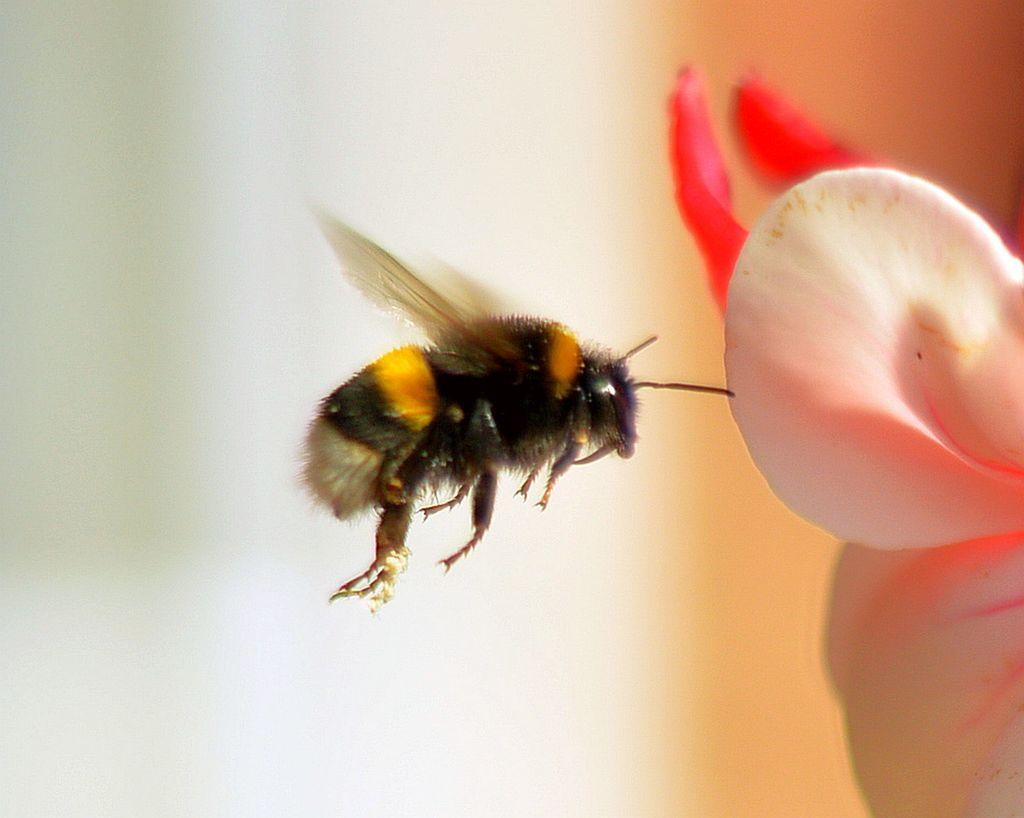What type of insect is in the image? There is a honey bee in the image. What is the honey bee interacting with in the image? The honey bee is interacting with a flower in the image. Can you describe the background of the image? The background of the image is blurry. What type of gun is being used to kick the meal in the image? There is no gun, kicking, or meal present in the image. 